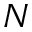Convert formula to latex. <formula><loc_0><loc_0><loc_500><loc_500>N</formula> 